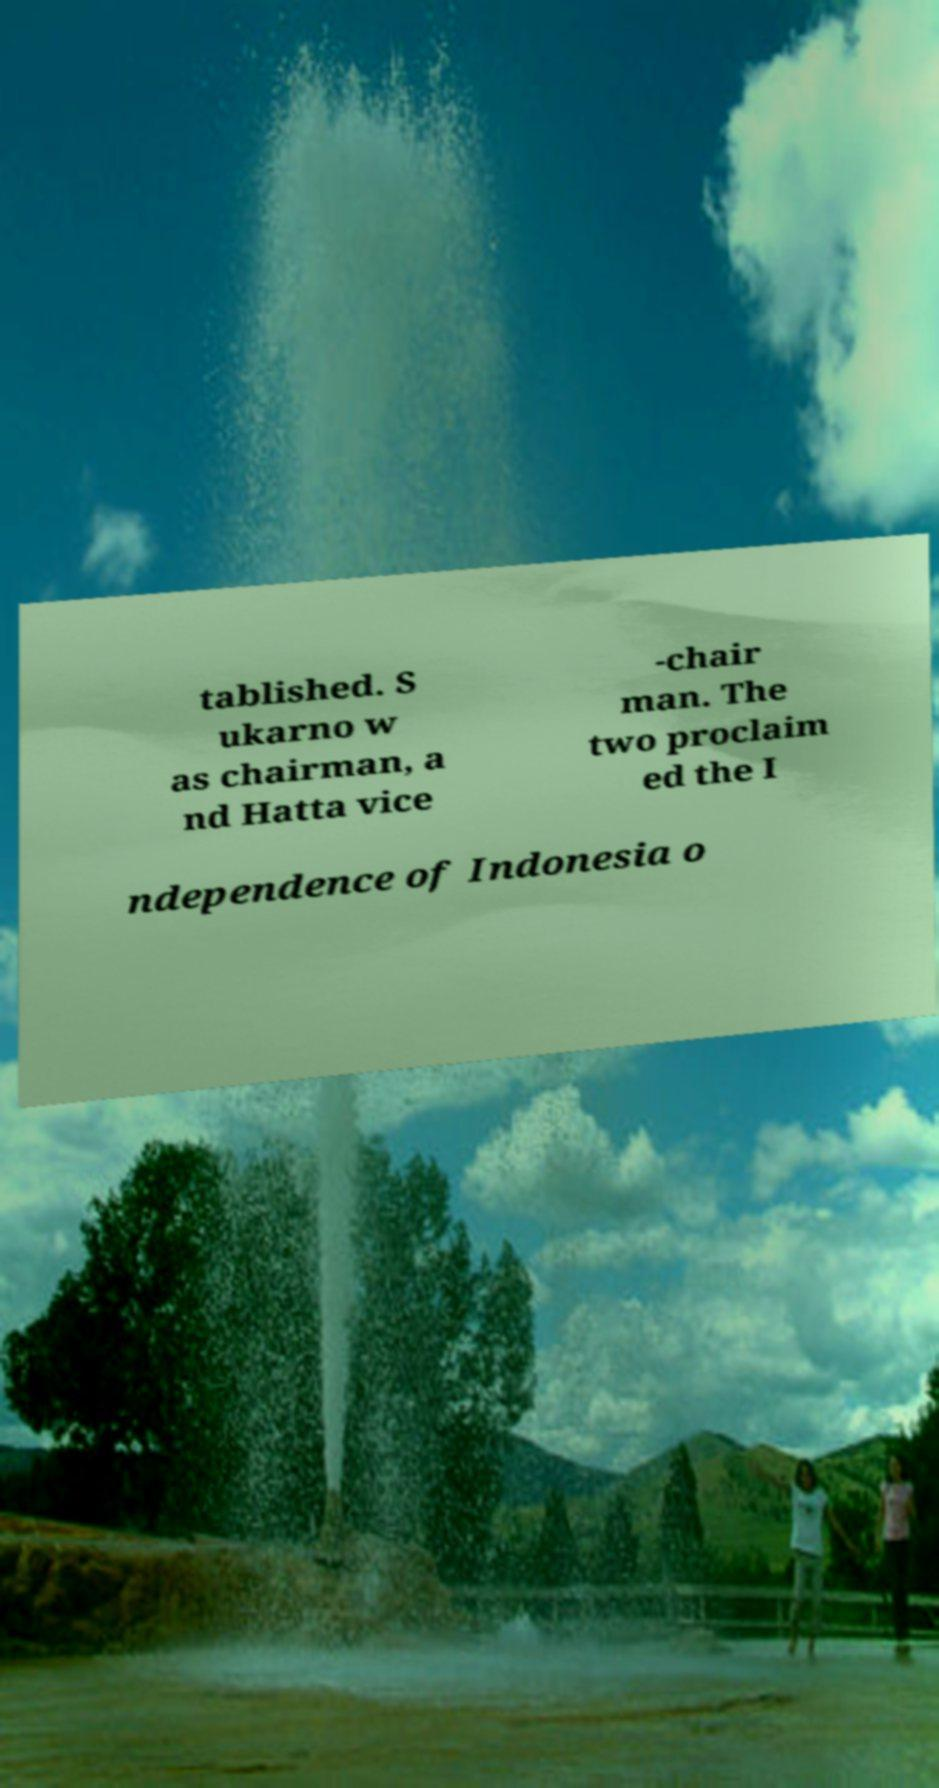Please identify and transcribe the text found in this image. tablished. S ukarno w as chairman, a nd Hatta vice -chair man. The two proclaim ed the I ndependence of Indonesia o 